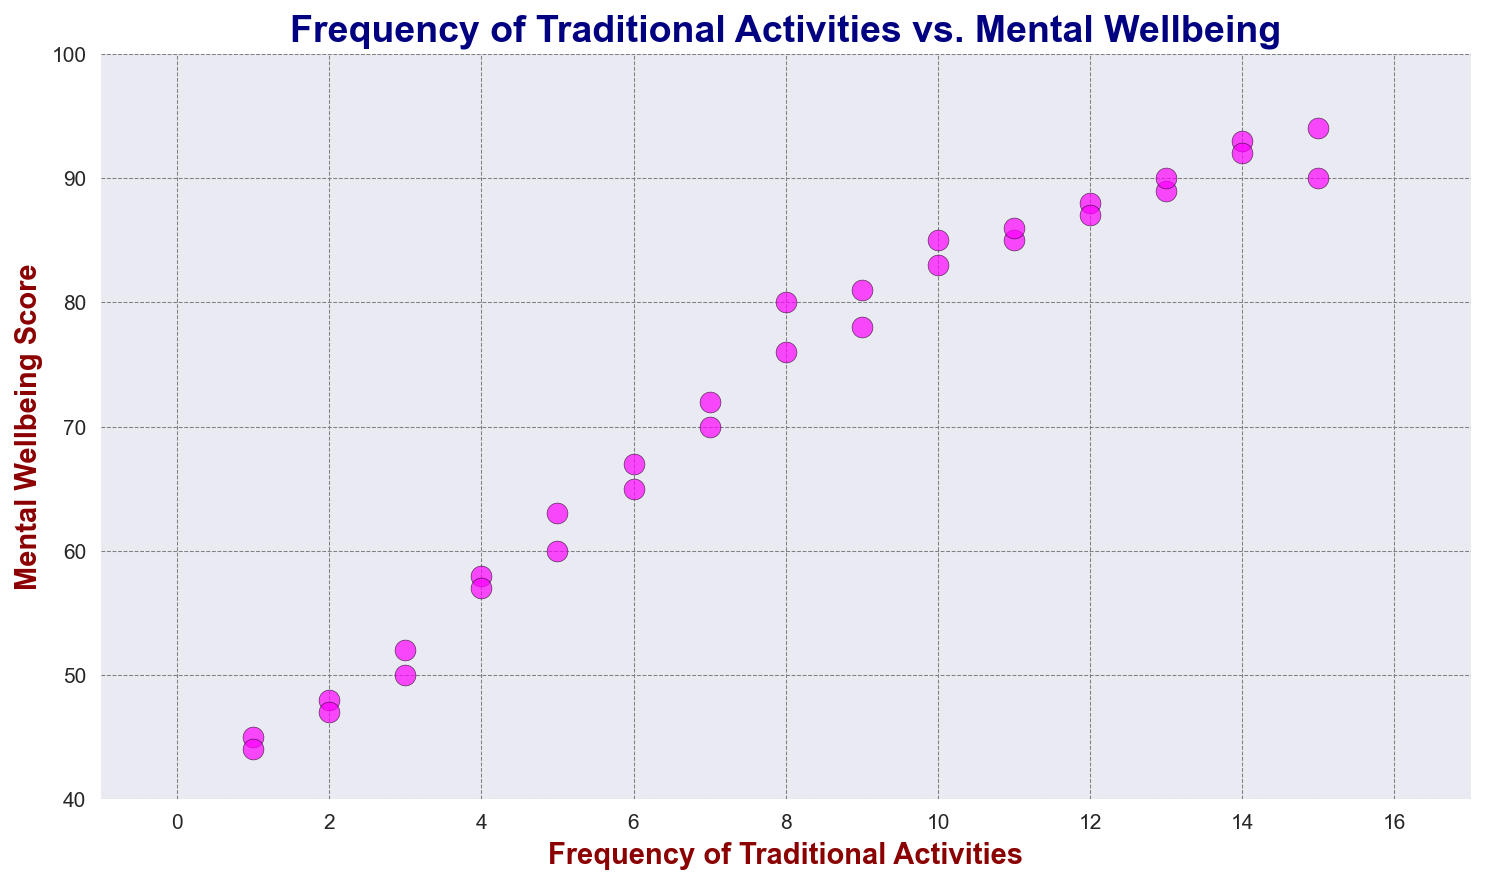What is the general trend between the frequency of traditional activities and mental well-being? By examining the scatter plot, we look for any apparent pattern or trend. The data points show a positive correlation, as higher frequencies of traditional activities are associated with higher mental well-being scores.
Answer: Positive correlation Which elder has the highest mental well-being score and what is their frequency of traditional activities? The data point with the highest y-value (mental well-being score) on the scatter plot is at a score of 94. This point corresponds to an elder who has the highest frequency of 15 traditional activities.
Answer: Elder ID 28, 15 activities How many elders have a mental well-being score above 80? By counting the number of data points that lie above the y-value of 80 on the scatter plot, we find the number of such elders. There are 10 data points above y=80.
Answer: 10 elders Is there any elder with a low frequency of traditional activities (1-3) but high mental well-being score (above 80)? By identifying data points in the leftmost (1-3 activities) region of the scatter plot and checking their corresponding y-value, we see if any points exceed 80. No data points in this low activity range meet the high mental well-being score criteria.
Answer: No What is the difference in mental well-being scores between elders with 15 activities and those with 1 activity? Firstly, identify the data points corresponding to 15 and 1 activities from the scatter plot. Compare their y-values. For 15 activities, the score is 94. For 1 activity, the highest is 45. The difference is 94 - 45.
Answer: 49 points Which elders have a frequency of traditional activities between 10 and 15 and what are their corresponding mental well-being scores? By locating data points within the x-value range of 10 to 15 on the scatter plot and reading their corresponding y-values, note down the pairs. Elders with these frequencies are: (10, 85), (11, 85), (11, 86), (12, 87), (12, 88), (13, 89), (13, 90), (14, 92), (14, 93), (15, 94).
Answer: Elders with IDs corresponding to various activities ranging 85-94 Which elder shows the lowest mental well-being score and what is their frequency of traditional activities? Identify the data point with the lowest y-value on the scatter plot. The lowest mental well-being score is 44 corresponding to a frequency of 1 traditional activity.
Answer: Elder ID 30, 1 activity What is the average mental well-being score for elders with a frequency of 10 traditional activities? From the scatter plot, locate the data points where the x-value is 10. The y-values for these are two points: 85 and 83. Average them: (85 + 83) / 2 = 84.
Answer: 84 Between activities frequencies of 5 and 7, how does the mental well-being score vary? Identify data points with x-values of 5, 6, and 7, and compare their y-values: For 5 activities, scores are 60, 63, for 6 activities, scores are 65, 67, and for 7 activities, scores are 70, 72. The trend shows increasing mental well-being scores as frequency increases.
Answer: Increasing trend 